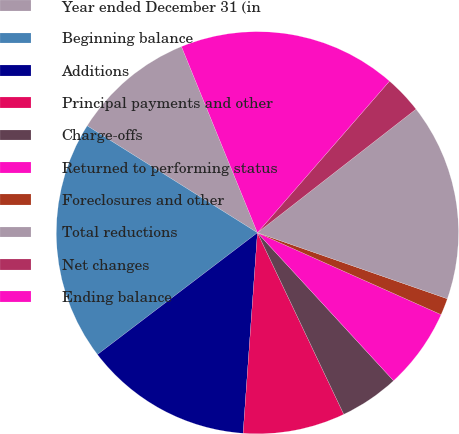<chart> <loc_0><loc_0><loc_500><loc_500><pie_chart><fcel>Year ended December 31 (in<fcel>Beginning balance<fcel>Additions<fcel>Principal payments and other<fcel>Charge-offs<fcel>Returned to performing status<fcel>Foreclosures and other<fcel>Total reductions<fcel>Net changes<fcel>Ending balance<nl><fcel>9.91%<fcel>19.28%<fcel>13.51%<fcel>8.2%<fcel>4.77%<fcel>6.49%<fcel>1.35%<fcel>15.86%<fcel>3.06%<fcel>17.57%<nl></chart> 